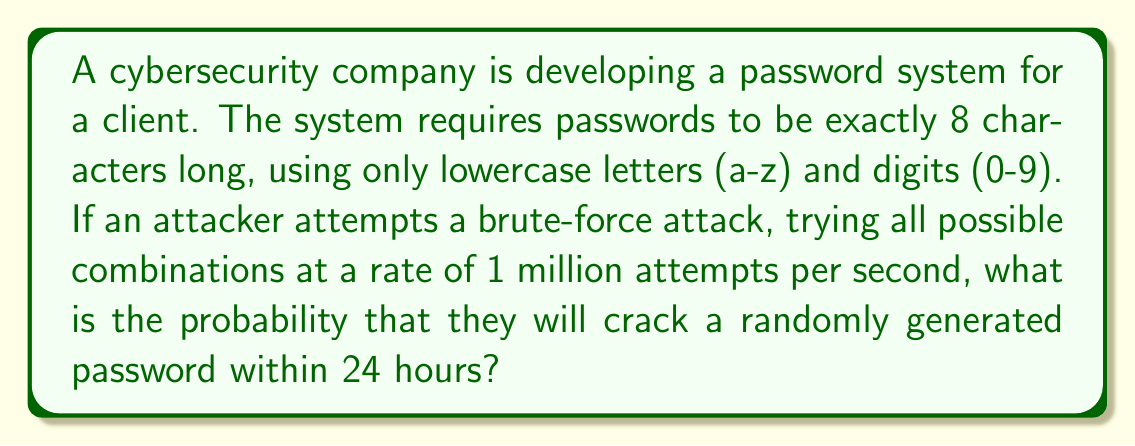Give your solution to this math problem. Let's approach this step-by-step:

1) First, we need to calculate the total number of possible passwords:
   - There are 26 lowercase letters and 10 digits, so 36 possible characters for each position.
   - The password is 8 characters long.
   - Total number of possible passwords = $36^8$

2) Now, let's calculate how many attempts the attacker can make in 24 hours:
   - Attempts per second = 1,000,000
   - Seconds in 24 hours = 24 * 60 * 60 = 86,400
   - Total attempts in 24 hours = $1,000,000 * 86,400 = 86,400,000,000$

3) The probability of success is the number of attempts divided by the total number of possible passwords:

   $$P(\text{success}) = \frac{\text{Number of attempts}}{\text{Total possible passwords}}$$

   $$P(\text{success}) = \frac{86,400,000,000}{36^8}$$

4) Let's calculate this:
   $$36^8 = 2,821,109,907,456$$
   
   $$P(\text{success}) = \frac{86,400,000,000}{2,821,109,907,456} \approx 0.0306$$

5) Convert to a percentage:
   $0.0306 * 100\% = 3.06\%$

Therefore, the probability of the attacker successfully cracking the password within 24 hours is approximately 3.06%.
Answer: 3.06% 